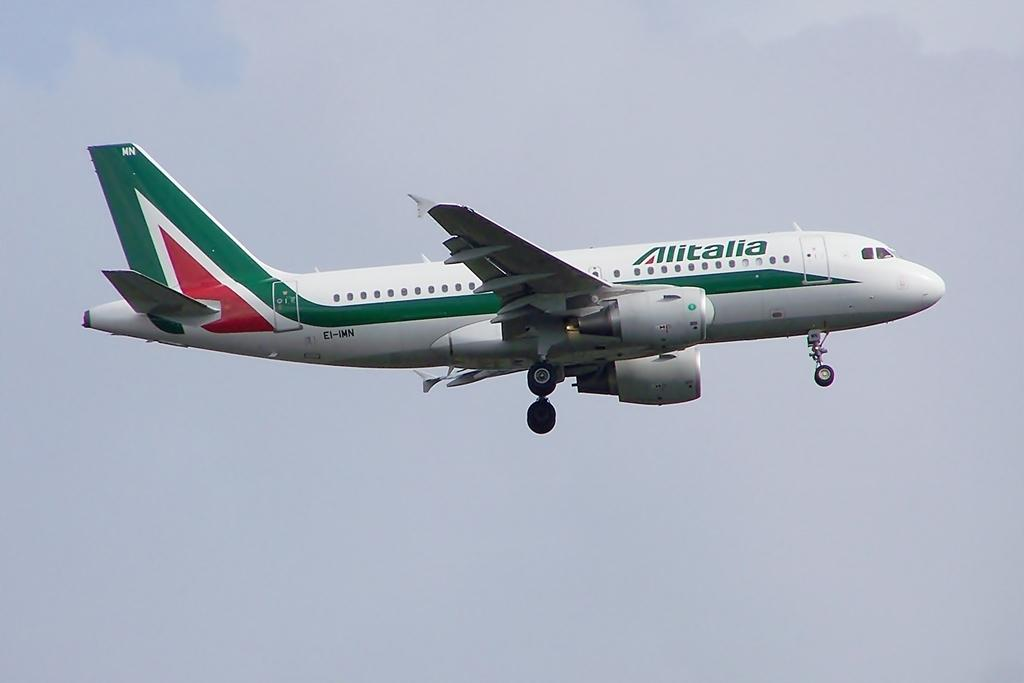Provide a one-sentence caption for the provided image. landing gears down on white airliner with green stripe and Alitalia in green lettering. 